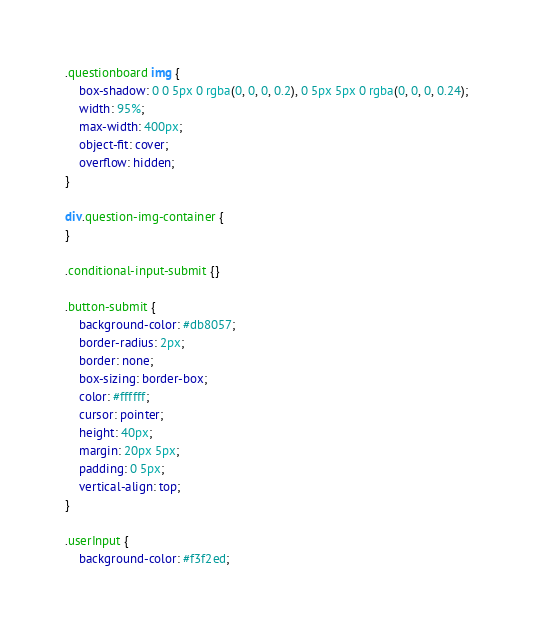<code> <loc_0><loc_0><loc_500><loc_500><_CSS_>.questionboard img {
	box-shadow: 0 0 5px 0 rgba(0, 0, 0, 0.2), 0 5px 5px 0 rgba(0, 0, 0, 0.24);
	width: 95%;
	max-width: 400px;
	object-fit: cover;
	overflow: hidden;
}

div.question-img-container {
}

.conditional-input-submit {}

.button-submit {
	background-color: #db8057;
	border-radius: 2px;
	border: none;
	box-sizing: border-box;
	color: #ffffff;
	cursor: pointer;
	height: 40px;
	margin: 20px 5px;
	padding: 0 5px;
	vertical-align: top;
}

.userInput {
	background-color: #f3f2ed;</code> 